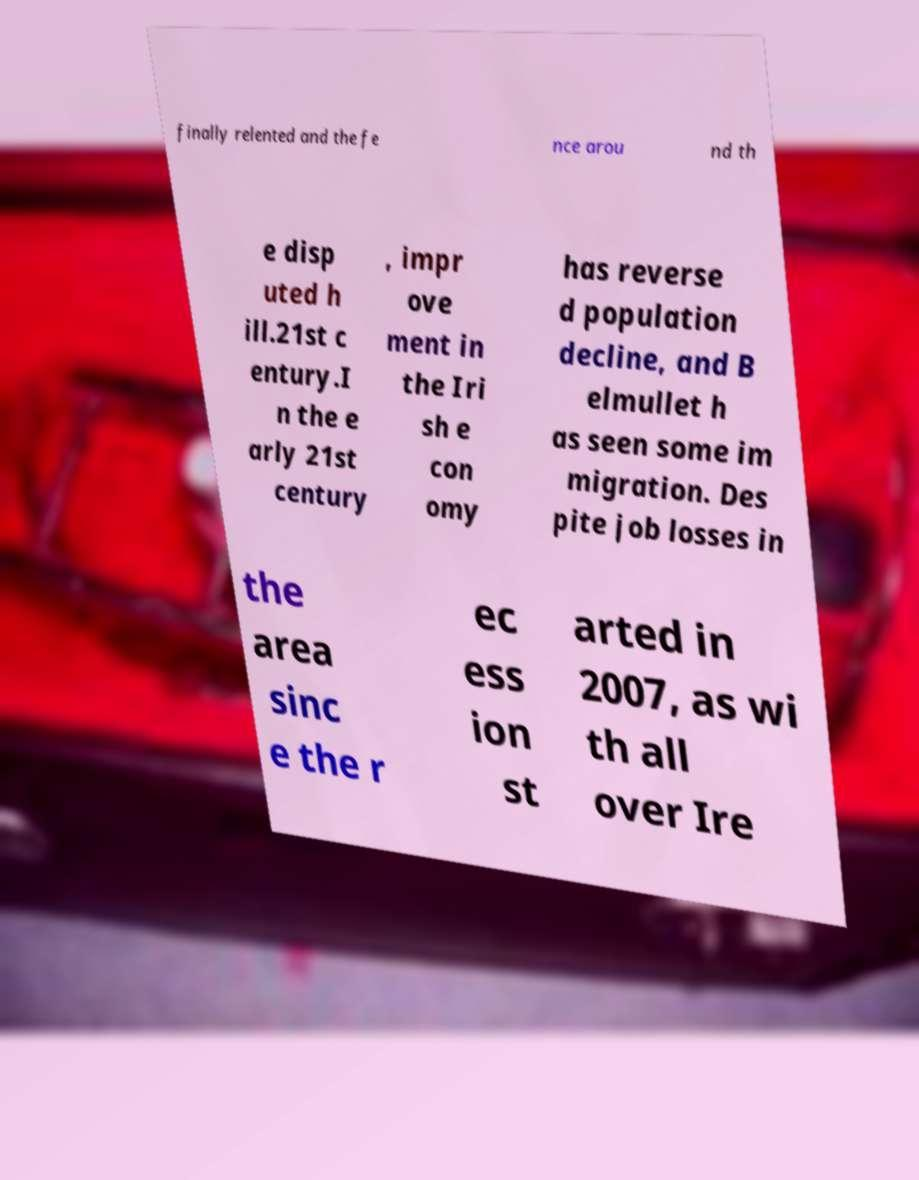What messages or text are displayed in this image? I need them in a readable, typed format. finally relented and the fe nce arou nd th e disp uted h ill.21st c entury.I n the e arly 21st century , impr ove ment in the Iri sh e con omy has reverse d population decline, and B elmullet h as seen some im migration. Des pite job losses in the area sinc e the r ec ess ion st arted in 2007, as wi th all over Ire 